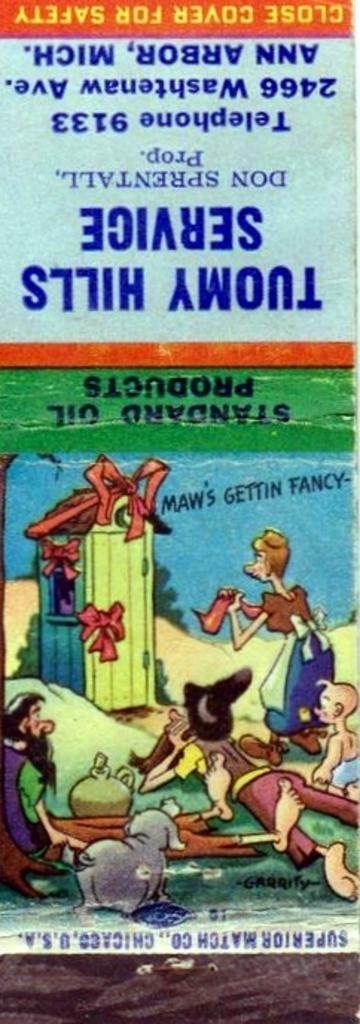<image>
Create a compact narrative representing the image presented. An advertisement for Tuomy Hills Service's standard oil products. 